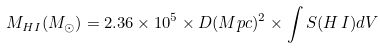Convert formula to latex. <formula><loc_0><loc_0><loc_500><loc_500>M _ { H I } ( M _ { \odot } ) = 2 . 3 6 \times 1 0 ^ { 5 } \times D ( M p c ) ^ { 2 } \times \int S ( H \, I ) d V</formula> 